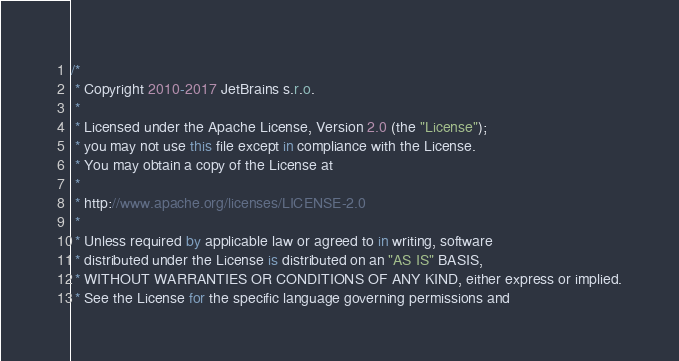Convert code to text. <code><loc_0><loc_0><loc_500><loc_500><_Kotlin_>/*
 * Copyright 2010-2017 JetBrains s.r.o.
 *
 * Licensed under the Apache License, Version 2.0 (the "License");
 * you may not use this file except in compliance with the License.
 * You may obtain a copy of the License at
 *
 * http://www.apache.org/licenses/LICENSE-2.0
 *
 * Unless required by applicable law or agreed to in writing, software
 * distributed under the License is distributed on an "AS IS" BASIS,
 * WITHOUT WARRANTIES OR CONDITIONS OF ANY KIND, either express or implied.
 * See the License for the specific language governing permissions and</code> 